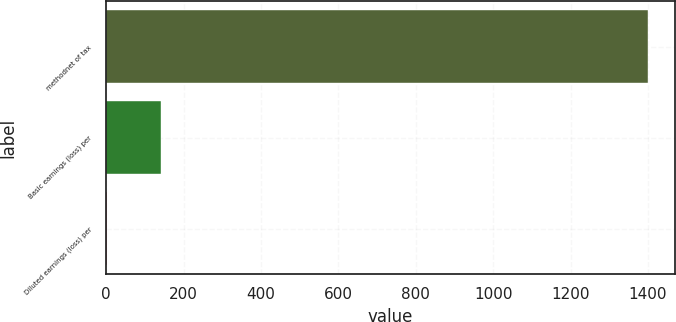Convert chart to OTSL. <chart><loc_0><loc_0><loc_500><loc_500><bar_chart><fcel>methodnet of tax<fcel>Basic earnings (loss) per<fcel>Diluted earnings (loss) per<nl><fcel>1399<fcel>140.77<fcel>0.97<nl></chart> 